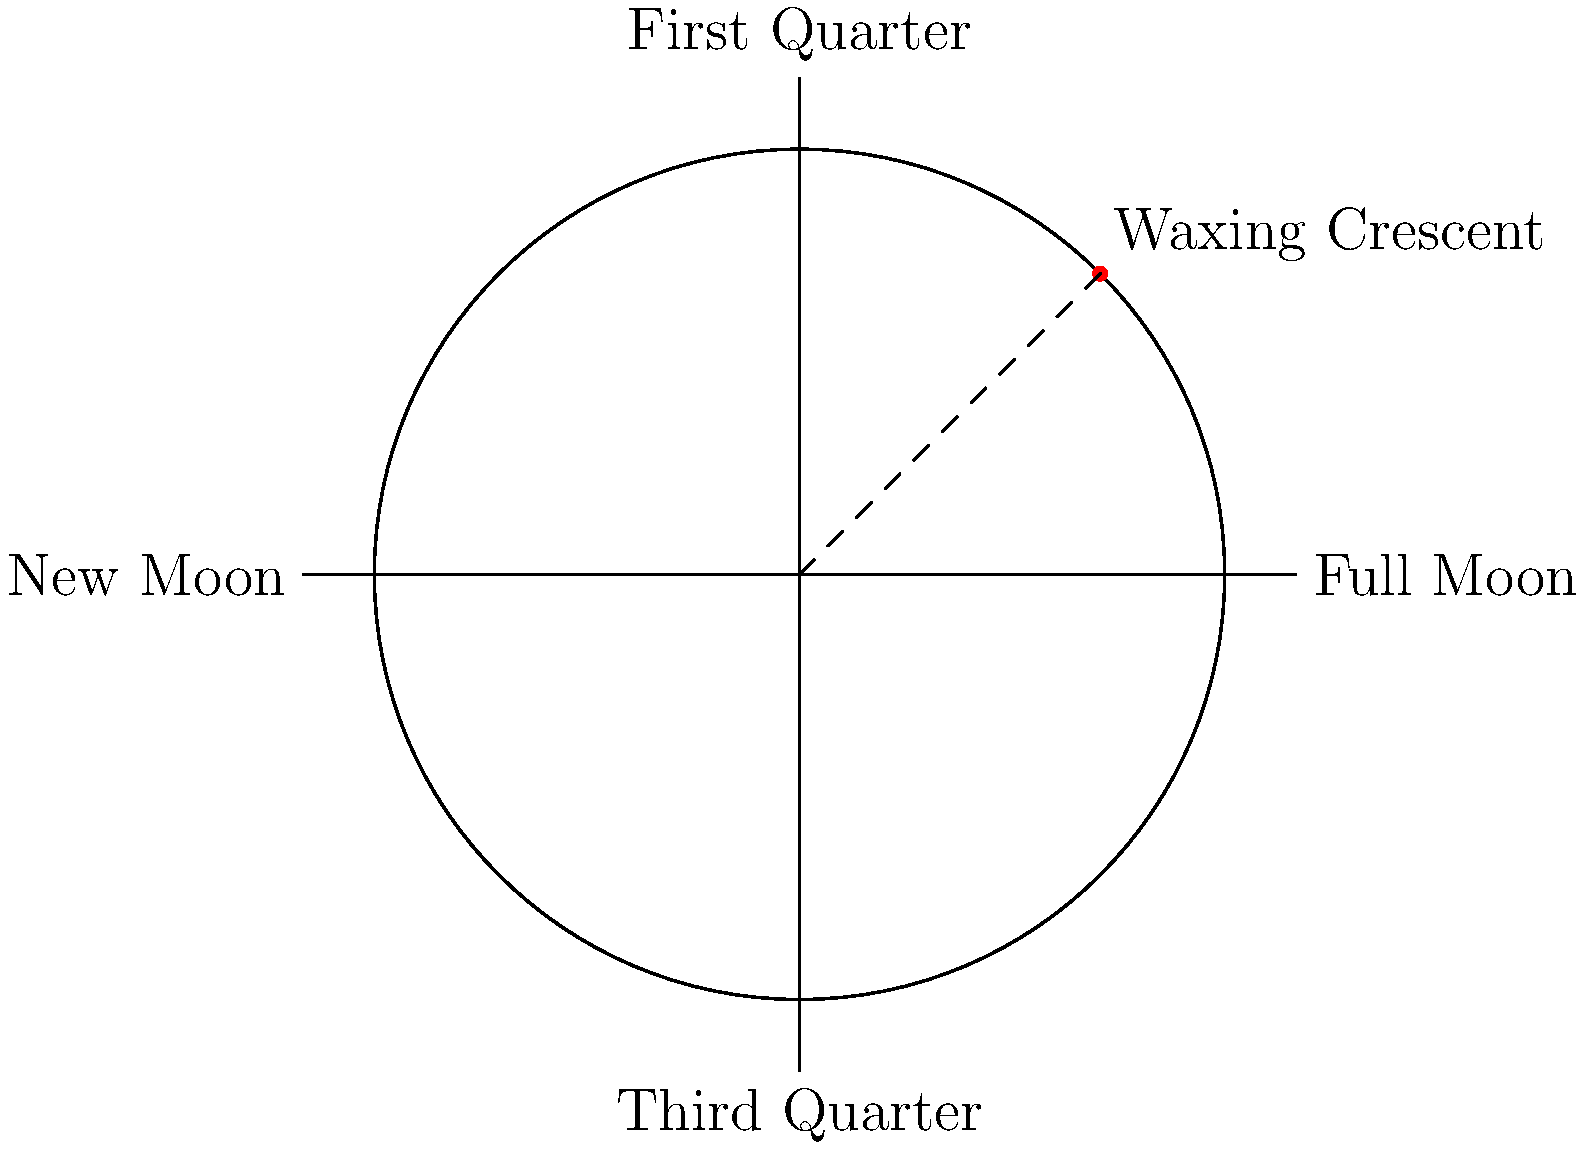In the circular coordinate system representing the phases of the moon, a red dot is placed at a 45-degree angle from the positive x-axis. Which phase of the moon does this position most closely represent, and what direction is the moon "moving" in at this point? To answer this question, let's break it down step-by-step:

1. The circular coordinate system represents the lunar cycle, with the following key points:
   - The positive x-axis (right) represents the Full Moon
   - The negative x-axis (left) represents the New Moon
   - The positive y-axis (top) represents the First Quarter
   - The negative y-axis (bottom) represents the Third Quarter

2. The red dot is placed at a 45-degree angle from the positive x-axis, which puts it between the New Moon and the First Quarter.

3. This position corresponds to the Waxing Crescent phase of the moon. In this phase, less than half of the moon's illuminated surface is visible from Earth, and it appears as a crescent shape.

4. The term "waxing" indicates that the visible portion of the moon is increasing. This means the moon is "moving" counterclockwise in this representation.

5. The progression of lunar phases in this circular system goes:
   New Moon → Waxing Crescent → First Quarter → Waxing Gibbous → Full Moon → Waning Gibbous → Third Quarter → Waning Crescent → New Moon

Therefore, at the position indicated by the red dot, the moon is in the Waxing Crescent phase and is moving counterclockwise (or waxing) towards the First Quarter.
Answer: Waxing Crescent, moving counterclockwise 